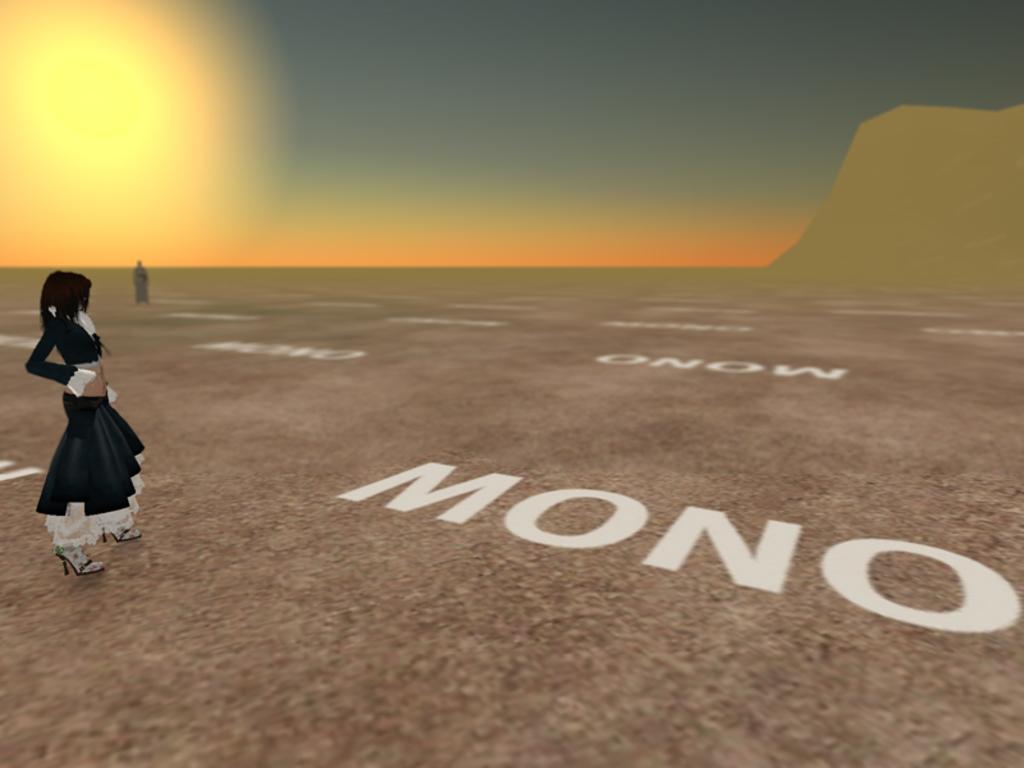Describe this image in one or two sentences. This picture describes about animation. 